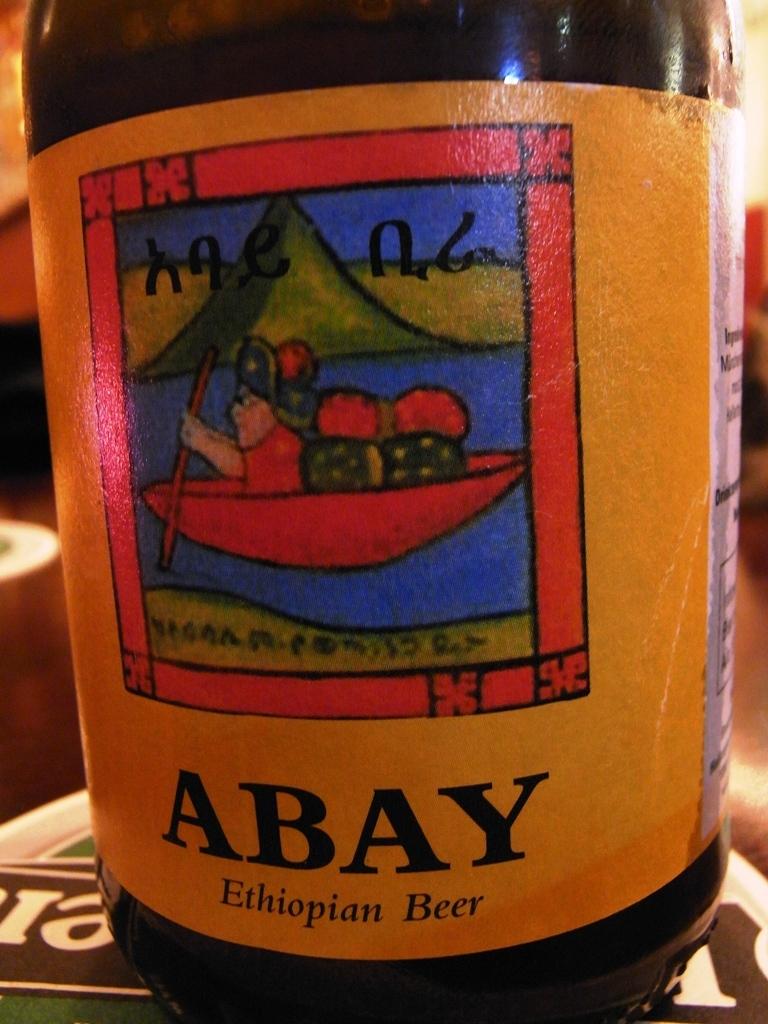What country does this beer come from?
Give a very brief answer. Ethiopia. What is the name of the beer?
Offer a very short reply. Abay. 